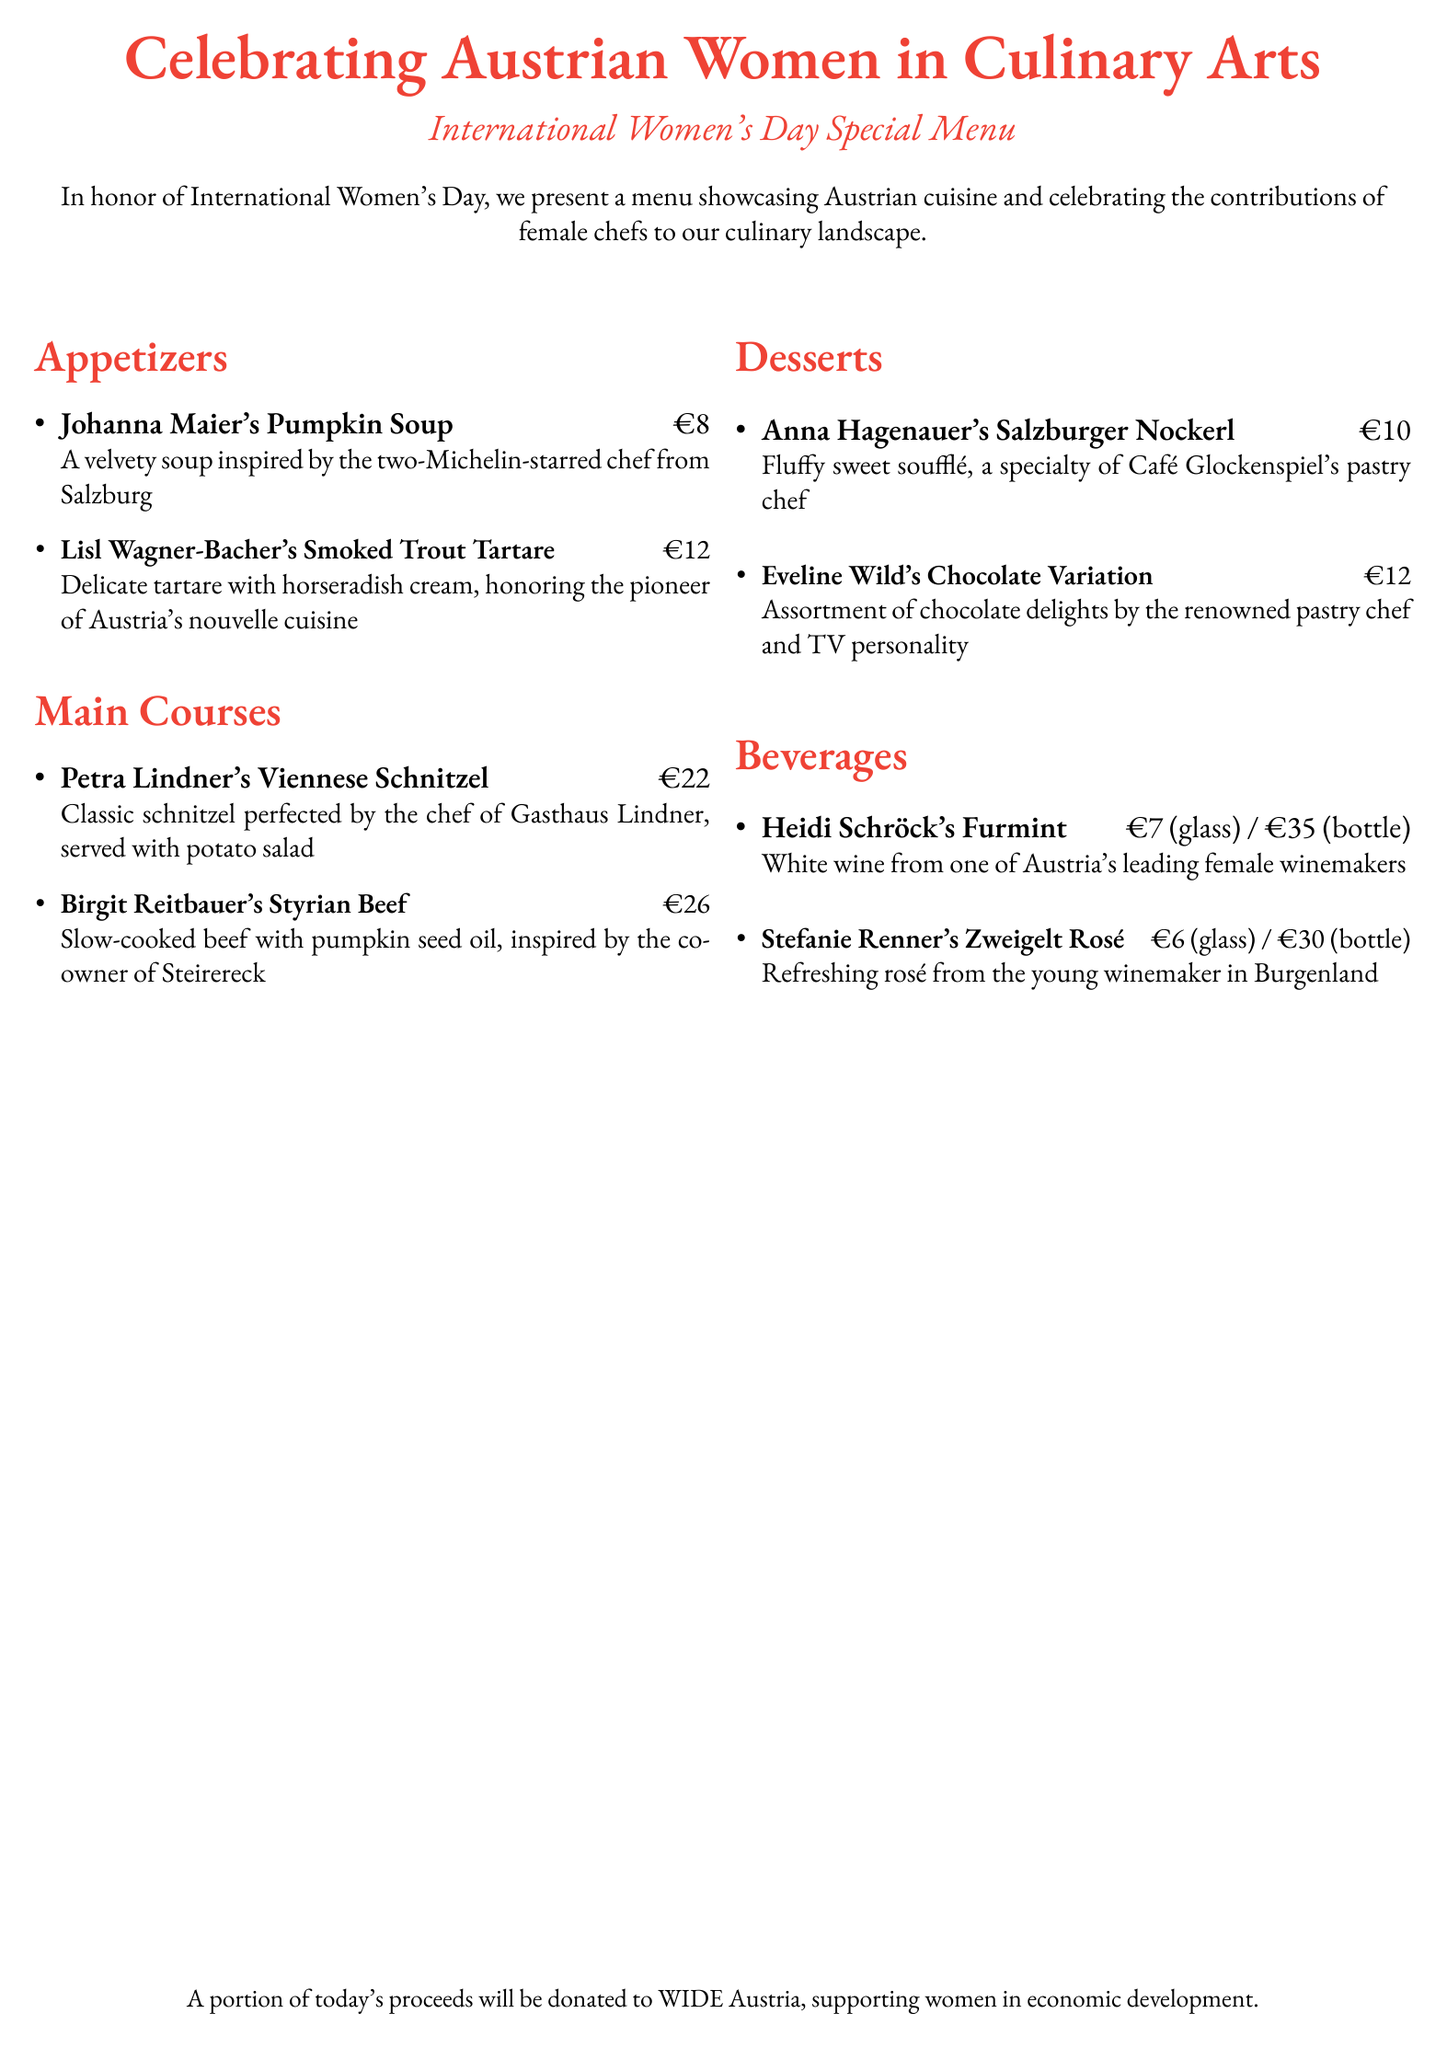What is the price of Johanna Maier's Pumpkin Soup? The price is listed next to the dish name in the appetizers section.
Answer: €8 Who is the chef associated with the Smoked Trout Tartare? The chef's name is specified in the description of the appetizer.
Answer: Lisl Wagner-Bacher What is the main ingredient in Birgit Reitbauer's dish? The dish description mentions the key ingredient that the dish is centered around.
Answer: Beef How much does a glass of Heidi Schröck's Furmint wine cost? The price for the wine is provided in the beverages section alongside its description.
Answer: €7 Which dessert is a specialty of Café Glockenspiel's pastry chef? The description of the dessert identifies the specific pastry chef associated with it.
Answer: Salzburger Nockerl What type of cuisine is being celebrated in this menu? The document highlights the cuisine featured in the menu's title and description.
Answer: Austrian How many appetizers are listed on the menu? The number can be counted from the items in the appetizers section.
Answer: 2 What is the beverage category in this menu? The sections of the document can be analyzed to identify the categories present.
Answer: Beverages Which chef is known for a two-Michelin-star restaurant? The document specifies which chef has recognized culinary credentials in the menu items.
Answer: Johanna Maier 